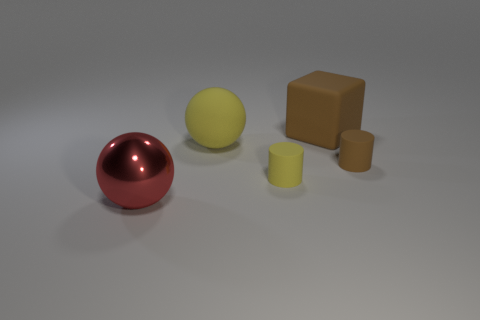Add 1 small yellow matte objects. How many objects exist? 6 Subtract all blocks. How many objects are left? 4 Subtract all tiny matte cylinders. Subtract all small things. How many objects are left? 1 Add 5 red spheres. How many red spheres are left? 6 Add 1 brown rubber cylinders. How many brown rubber cylinders exist? 2 Subtract 0 cyan spheres. How many objects are left? 5 